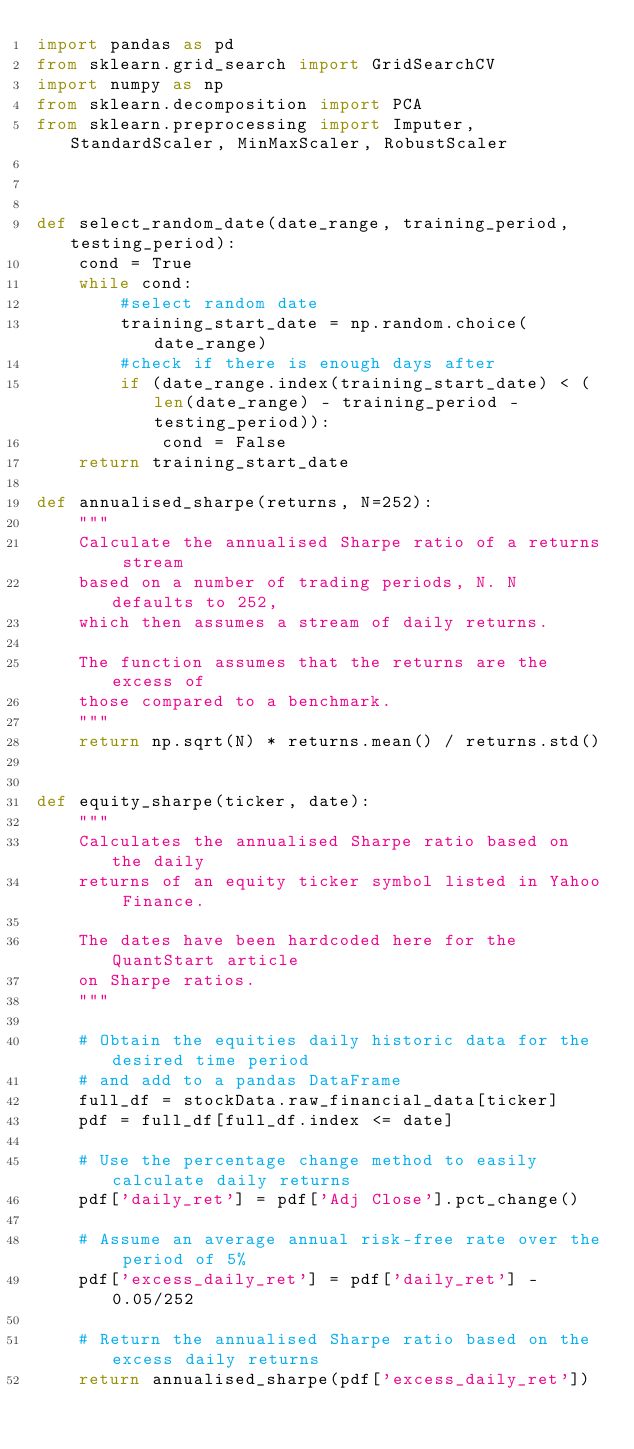<code> <loc_0><loc_0><loc_500><loc_500><_Python_>import pandas as pd
from sklearn.grid_search import GridSearchCV
import numpy as np
from sklearn.decomposition import PCA
from sklearn.preprocessing import Imputer, StandardScaler, MinMaxScaler, RobustScaler



def select_random_date(date_range, training_period, testing_period):
    cond = True
    while cond:
        #select random date
        training_start_date = np.random.choice(date_range)
        #check if there is enough days after 
        if (date_range.index(training_start_date) < (len(date_range) - training_period - testing_period)):
            cond = False
    return training_start_date    

def annualised_sharpe(returns, N=252):
    """
    Calculate the annualised Sharpe ratio of a returns stream 
    based on a number of trading periods, N. N defaults to 252,
    which then assumes a stream of daily returns.

    The function assumes that the returns are the excess of 
    those compared to a benchmark.
    """
    return np.sqrt(N) * returns.mean() / returns.std()


def equity_sharpe(ticker, date):
    """
    Calculates the annualised Sharpe ratio based on the daily
    returns of an equity ticker symbol listed in Yahoo Finance.

    The dates have been hardcoded here for the QuantStart article 
    on Sharpe ratios.
    """

    # Obtain the equities daily historic data for the desired time period
    # and add to a pandas DataFrame
    full_df = stockData.raw_financial_data[ticker]
    pdf = full_df[full_df.index <= date]

    # Use the percentage change method to easily calculate daily returns
    pdf['daily_ret'] = pdf['Adj Close'].pct_change()

    # Assume an average annual risk-free rate over the period of 5%
    pdf['excess_daily_ret'] = pdf['daily_ret'] - 0.05/252

    # Return the annualised Sharpe ratio based on the excess daily returns
    return annualised_sharpe(pdf['excess_daily_ret'])
</code> 